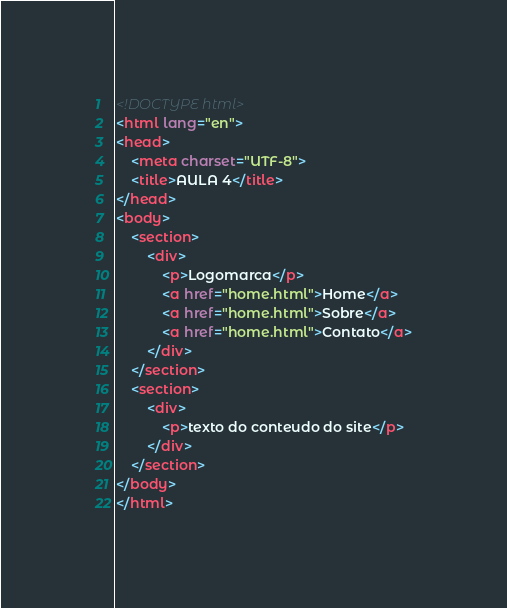<code> <loc_0><loc_0><loc_500><loc_500><_HTML_><!DOCTYPE html>
<html lang="en">
<head>
    <meta charset="UTF-8">
    <title>AULA 4</title>
</head>
<body>
    <section>
        <div>
            <p>Logomarca</p> 
            <a href="home.html">Home</a>
            <a href="home.html">Sobre</a>
            <a href="home.html">Contato</a>
        </div>
    </section>
    <section>
        <div>
            <p>texto do conteudo do site</p>
        </div>
    </section>
</body>
</html></code> 